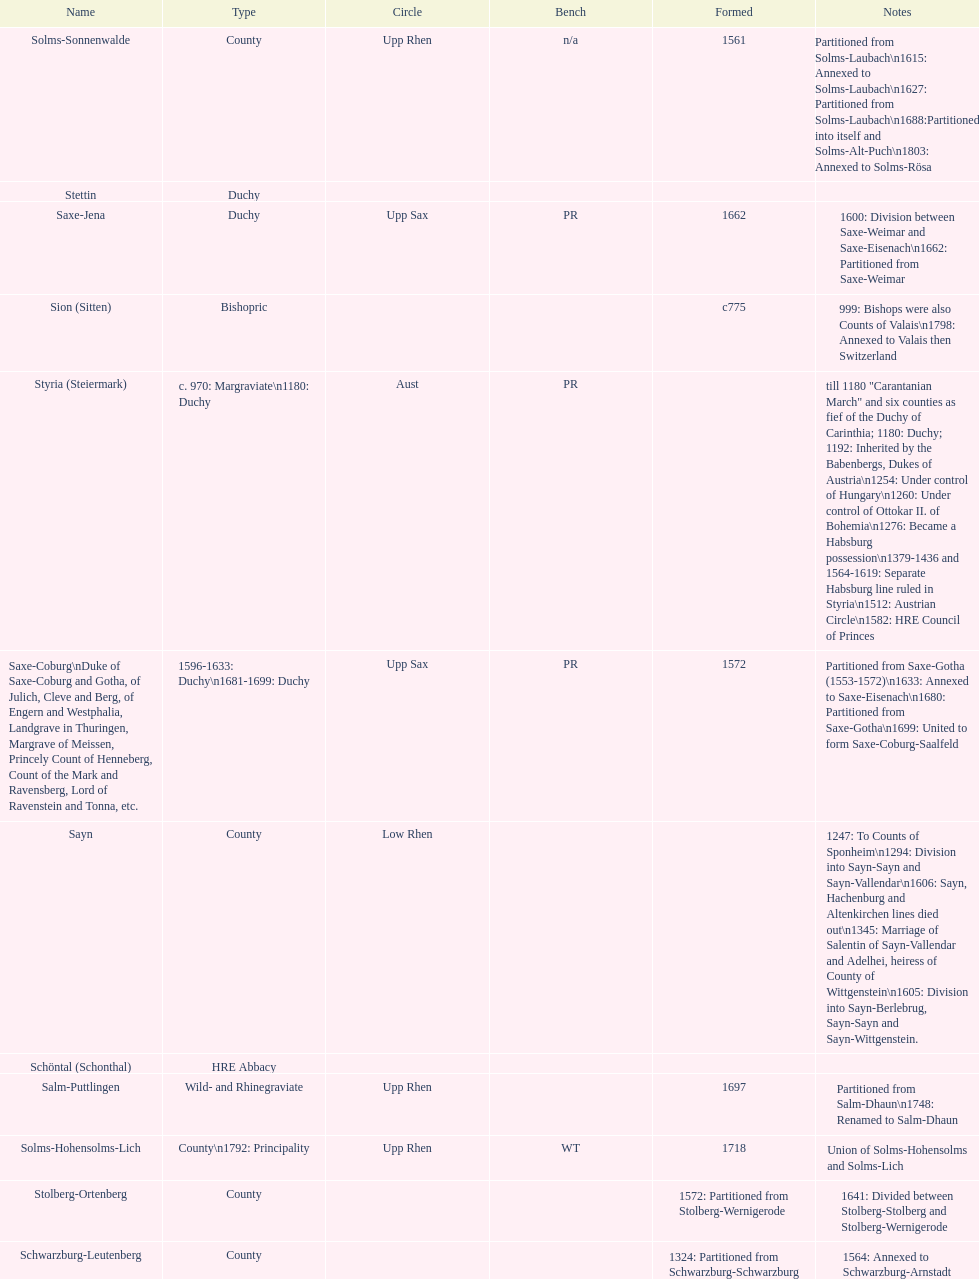Which bench is represented the most? PR. 